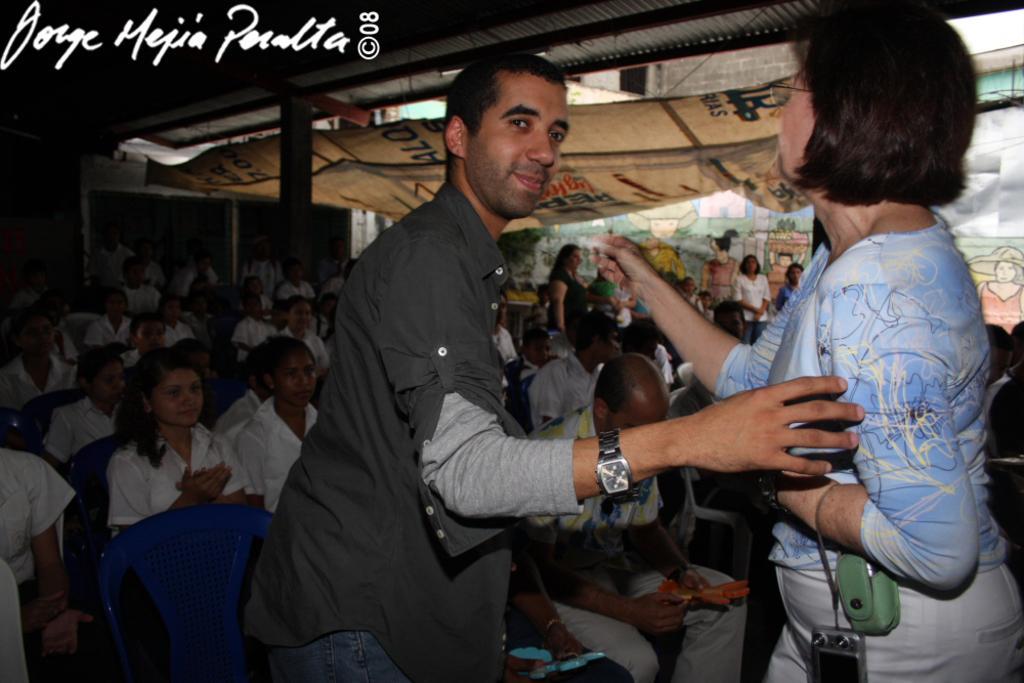In one or two sentences, can you explain what this image depicts? In this picture I can see a man and a woman are standing in the middle, in the background a group of people are sitting on the chairs, in the top left hand side I can see the text. 